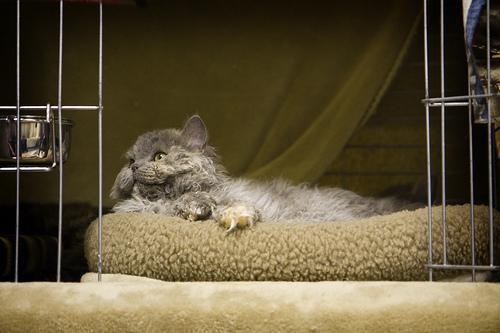How many cats are shown?
Give a very brief answer. 1. 